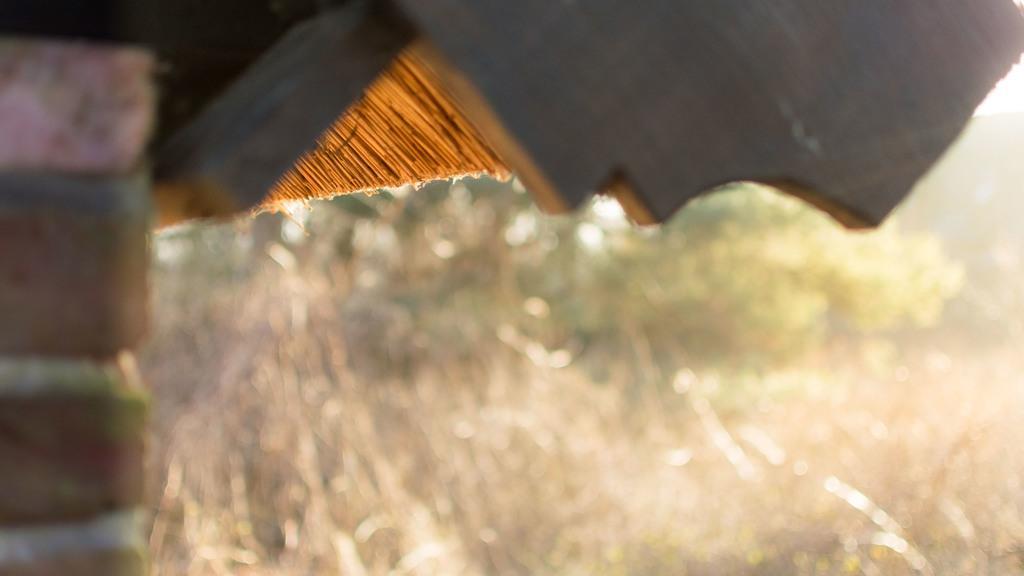Please provide a concise description of this image. On the left side of the image there is a house with red bricks. On the right side of the image there is a dry grass and trees. 